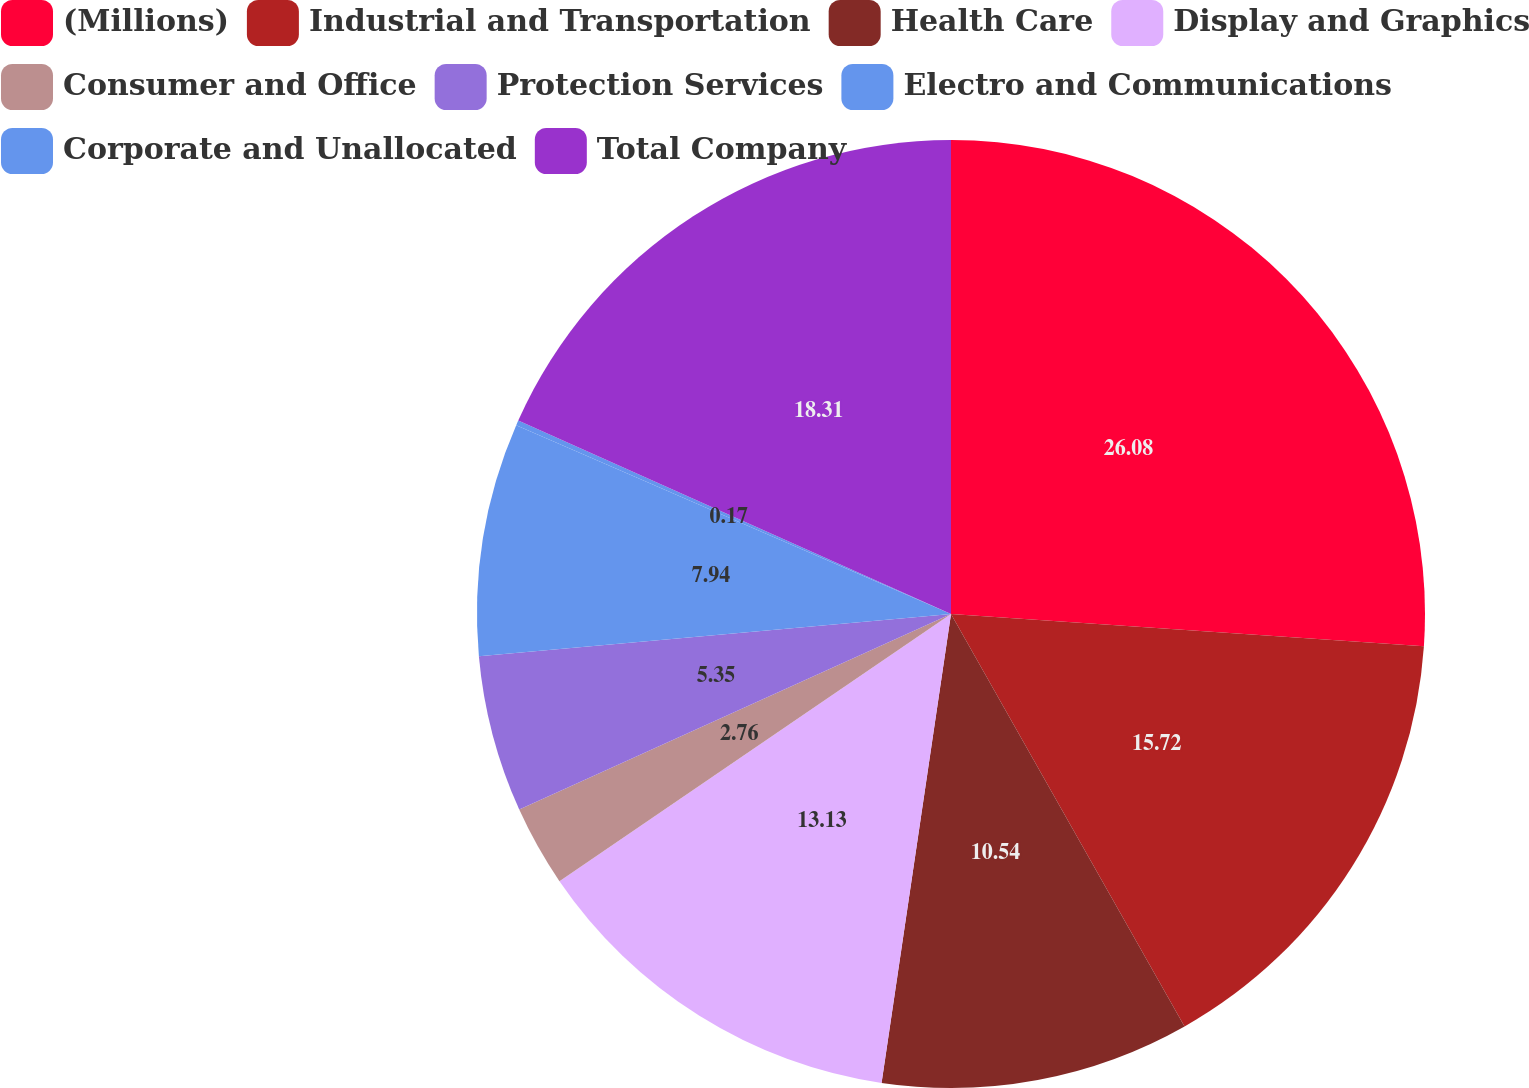Convert chart. <chart><loc_0><loc_0><loc_500><loc_500><pie_chart><fcel>(Millions)<fcel>Industrial and Transportation<fcel>Health Care<fcel>Display and Graphics<fcel>Consumer and Office<fcel>Protection Services<fcel>Electro and Communications<fcel>Corporate and Unallocated<fcel>Total Company<nl><fcel>26.08%<fcel>15.72%<fcel>10.54%<fcel>13.13%<fcel>2.76%<fcel>5.35%<fcel>7.94%<fcel>0.17%<fcel>18.31%<nl></chart> 